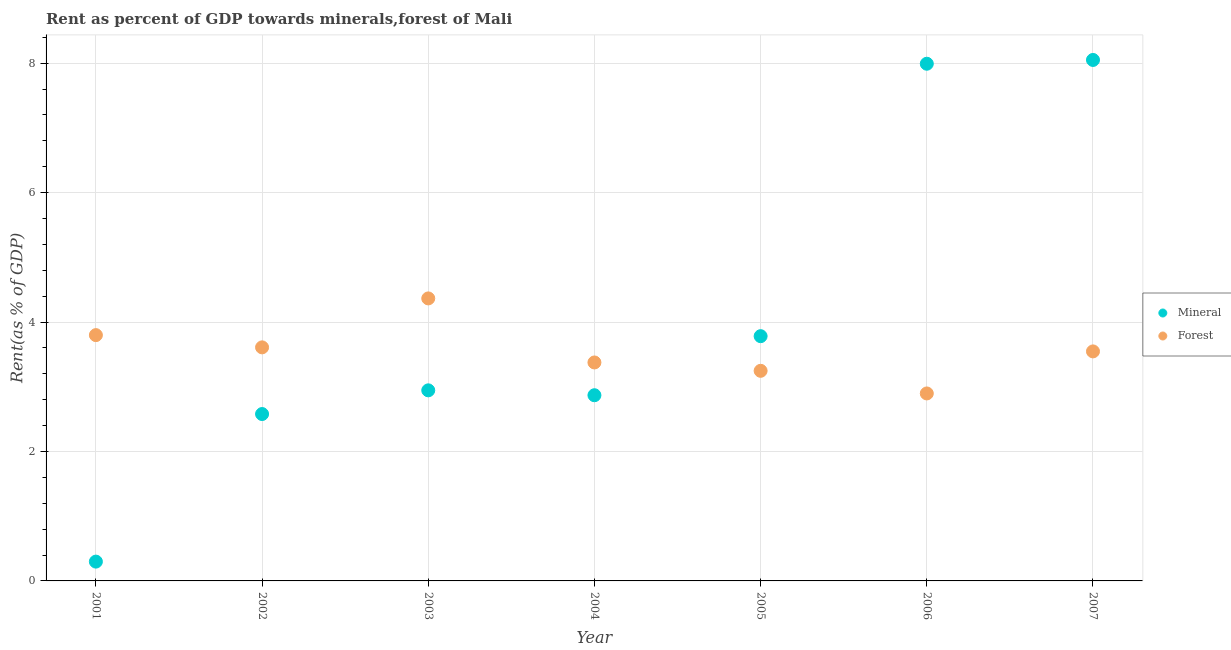How many different coloured dotlines are there?
Ensure brevity in your answer.  2. What is the mineral rent in 2002?
Your answer should be compact. 2.58. Across all years, what is the maximum forest rent?
Provide a short and direct response. 4.36. Across all years, what is the minimum mineral rent?
Make the answer very short. 0.3. In which year was the mineral rent maximum?
Your answer should be compact. 2007. What is the total mineral rent in the graph?
Your answer should be very brief. 28.51. What is the difference between the mineral rent in 2005 and that in 2006?
Keep it short and to the point. -4.21. What is the difference between the mineral rent in 2004 and the forest rent in 2005?
Your answer should be compact. -0.38. What is the average mineral rent per year?
Your response must be concise. 4.07. In the year 2001, what is the difference between the mineral rent and forest rent?
Offer a terse response. -3.5. In how many years, is the forest rent greater than 7.2 %?
Give a very brief answer. 0. What is the ratio of the mineral rent in 2005 to that in 2006?
Give a very brief answer. 0.47. What is the difference between the highest and the second highest forest rent?
Provide a short and direct response. 0.57. What is the difference between the highest and the lowest mineral rent?
Make the answer very short. 7.75. In how many years, is the forest rent greater than the average forest rent taken over all years?
Make the answer very short. 3. Does the mineral rent monotonically increase over the years?
Ensure brevity in your answer.  No. How many dotlines are there?
Your response must be concise. 2. What is the difference between two consecutive major ticks on the Y-axis?
Keep it short and to the point. 2. Does the graph contain grids?
Keep it short and to the point. Yes. Where does the legend appear in the graph?
Provide a short and direct response. Center right. How many legend labels are there?
Your answer should be very brief. 2. What is the title of the graph?
Offer a terse response. Rent as percent of GDP towards minerals,forest of Mali. What is the label or title of the X-axis?
Offer a very short reply. Year. What is the label or title of the Y-axis?
Your response must be concise. Rent(as % of GDP). What is the Rent(as % of GDP) in Mineral in 2001?
Your answer should be very brief. 0.3. What is the Rent(as % of GDP) of Forest in 2001?
Offer a very short reply. 3.8. What is the Rent(as % of GDP) in Mineral in 2002?
Keep it short and to the point. 2.58. What is the Rent(as % of GDP) in Forest in 2002?
Your answer should be compact. 3.61. What is the Rent(as % of GDP) in Mineral in 2003?
Ensure brevity in your answer.  2.94. What is the Rent(as % of GDP) of Forest in 2003?
Provide a succinct answer. 4.36. What is the Rent(as % of GDP) in Mineral in 2004?
Provide a succinct answer. 2.87. What is the Rent(as % of GDP) in Forest in 2004?
Keep it short and to the point. 3.38. What is the Rent(as % of GDP) in Mineral in 2005?
Offer a terse response. 3.78. What is the Rent(as % of GDP) of Forest in 2005?
Your response must be concise. 3.25. What is the Rent(as % of GDP) in Mineral in 2006?
Your answer should be very brief. 7.99. What is the Rent(as % of GDP) in Forest in 2006?
Ensure brevity in your answer.  2.9. What is the Rent(as % of GDP) in Mineral in 2007?
Give a very brief answer. 8.05. What is the Rent(as % of GDP) of Forest in 2007?
Make the answer very short. 3.55. Across all years, what is the maximum Rent(as % of GDP) of Mineral?
Make the answer very short. 8.05. Across all years, what is the maximum Rent(as % of GDP) of Forest?
Make the answer very short. 4.36. Across all years, what is the minimum Rent(as % of GDP) of Mineral?
Offer a terse response. 0.3. Across all years, what is the minimum Rent(as % of GDP) in Forest?
Give a very brief answer. 2.9. What is the total Rent(as % of GDP) in Mineral in the graph?
Offer a very short reply. 28.51. What is the total Rent(as % of GDP) in Forest in the graph?
Give a very brief answer. 24.84. What is the difference between the Rent(as % of GDP) of Mineral in 2001 and that in 2002?
Your answer should be very brief. -2.28. What is the difference between the Rent(as % of GDP) of Forest in 2001 and that in 2002?
Keep it short and to the point. 0.19. What is the difference between the Rent(as % of GDP) of Mineral in 2001 and that in 2003?
Keep it short and to the point. -2.65. What is the difference between the Rent(as % of GDP) of Forest in 2001 and that in 2003?
Your answer should be compact. -0.57. What is the difference between the Rent(as % of GDP) in Mineral in 2001 and that in 2004?
Your answer should be compact. -2.57. What is the difference between the Rent(as % of GDP) in Forest in 2001 and that in 2004?
Make the answer very short. 0.42. What is the difference between the Rent(as % of GDP) in Mineral in 2001 and that in 2005?
Provide a short and direct response. -3.48. What is the difference between the Rent(as % of GDP) of Forest in 2001 and that in 2005?
Make the answer very short. 0.55. What is the difference between the Rent(as % of GDP) of Mineral in 2001 and that in 2006?
Ensure brevity in your answer.  -7.69. What is the difference between the Rent(as % of GDP) of Forest in 2001 and that in 2006?
Your answer should be very brief. 0.9. What is the difference between the Rent(as % of GDP) in Mineral in 2001 and that in 2007?
Offer a terse response. -7.75. What is the difference between the Rent(as % of GDP) of Forest in 2001 and that in 2007?
Make the answer very short. 0.25. What is the difference between the Rent(as % of GDP) of Mineral in 2002 and that in 2003?
Offer a terse response. -0.37. What is the difference between the Rent(as % of GDP) of Forest in 2002 and that in 2003?
Your answer should be compact. -0.76. What is the difference between the Rent(as % of GDP) of Mineral in 2002 and that in 2004?
Give a very brief answer. -0.29. What is the difference between the Rent(as % of GDP) in Forest in 2002 and that in 2004?
Your answer should be compact. 0.23. What is the difference between the Rent(as % of GDP) in Mineral in 2002 and that in 2005?
Keep it short and to the point. -1.2. What is the difference between the Rent(as % of GDP) of Forest in 2002 and that in 2005?
Offer a very short reply. 0.36. What is the difference between the Rent(as % of GDP) of Mineral in 2002 and that in 2006?
Make the answer very short. -5.41. What is the difference between the Rent(as % of GDP) of Forest in 2002 and that in 2006?
Offer a terse response. 0.71. What is the difference between the Rent(as % of GDP) in Mineral in 2002 and that in 2007?
Your answer should be very brief. -5.47. What is the difference between the Rent(as % of GDP) in Forest in 2002 and that in 2007?
Your response must be concise. 0.06. What is the difference between the Rent(as % of GDP) in Mineral in 2003 and that in 2004?
Make the answer very short. 0.08. What is the difference between the Rent(as % of GDP) in Forest in 2003 and that in 2004?
Your answer should be very brief. 0.99. What is the difference between the Rent(as % of GDP) in Mineral in 2003 and that in 2005?
Make the answer very short. -0.84. What is the difference between the Rent(as % of GDP) of Forest in 2003 and that in 2005?
Make the answer very short. 1.12. What is the difference between the Rent(as % of GDP) in Mineral in 2003 and that in 2006?
Provide a succinct answer. -5.05. What is the difference between the Rent(as % of GDP) of Forest in 2003 and that in 2006?
Keep it short and to the point. 1.47. What is the difference between the Rent(as % of GDP) of Mineral in 2003 and that in 2007?
Give a very brief answer. -5.1. What is the difference between the Rent(as % of GDP) of Forest in 2003 and that in 2007?
Give a very brief answer. 0.82. What is the difference between the Rent(as % of GDP) in Mineral in 2004 and that in 2005?
Keep it short and to the point. -0.91. What is the difference between the Rent(as % of GDP) of Forest in 2004 and that in 2005?
Your answer should be very brief. 0.13. What is the difference between the Rent(as % of GDP) of Mineral in 2004 and that in 2006?
Ensure brevity in your answer.  -5.12. What is the difference between the Rent(as % of GDP) of Forest in 2004 and that in 2006?
Your answer should be very brief. 0.48. What is the difference between the Rent(as % of GDP) in Mineral in 2004 and that in 2007?
Your answer should be compact. -5.18. What is the difference between the Rent(as % of GDP) in Forest in 2004 and that in 2007?
Provide a succinct answer. -0.17. What is the difference between the Rent(as % of GDP) in Mineral in 2005 and that in 2006?
Your answer should be very brief. -4.21. What is the difference between the Rent(as % of GDP) in Forest in 2005 and that in 2006?
Your answer should be compact. 0.35. What is the difference between the Rent(as % of GDP) in Mineral in 2005 and that in 2007?
Offer a very short reply. -4.27. What is the difference between the Rent(as % of GDP) of Forest in 2005 and that in 2007?
Your answer should be very brief. -0.3. What is the difference between the Rent(as % of GDP) of Mineral in 2006 and that in 2007?
Provide a succinct answer. -0.06. What is the difference between the Rent(as % of GDP) of Forest in 2006 and that in 2007?
Your response must be concise. -0.65. What is the difference between the Rent(as % of GDP) in Mineral in 2001 and the Rent(as % of GDP) in Forest in 2002?
Offer a very short reply. -3.31. What is the difference between the Rent(as % of GDP) in Mineral in 2001 and the Rent(as % of GDP) in Forest in 2003?
Offer a terse response. -4.07. What is the difference between the Rent(as % of GDP) of Mineral in 2001 and the Rent(as % of GDP) of Forest in 2004?
Make the answer very short. -3.08. What is the difference between the Rent(as % of GDP) of Mineral in 2001 and the Rent(as % of GDP) of Forest in 2005?
Your answer should be compact. -2.95. What is the difference between the Rent(as % of GDP) in Mineral in 2001 and the Rent(as % of GDP) in Forest in 2006?
Offer a very short reply. -2.6. What is the difference between the Rent(as % of GDP) in Mineral in 2001 and the Rent(as % of GDP) in Forest in 2007?
Offer a very short reply. -3.25. What is the difference between the Rent(as % of GDP) of Mineral in 2002 and the Rent(as % of GDP) of Forest in 2003?
Provide a succinct answer. -1.79. What is the difference between the Rent(as % of GDP) in Mineral in 2002 and the Rent(as % of GDP) in Forest in 2004?
Keep it short and to the point. -0.8. What is the difference between the Rent(as % of GDP) of Mineral in 2002 and the Rent(as % of GDP) of Forest in 2005?
Keep it short and to the point. -0.67. What is the difference between the Rent(as % of GDP) in Mineral in 2002 and the Rent(as % of GDP) in Forest in 2006?
Make the answer very short. -0.32. What is the difference between the Rent(as % of GDP) in Mineral in 2002 and the Rent(as % of GDP) in Forest in 2007?
Keep it short and to the point. -0.97. What is the difference between the Rent(as % of GDP) of Mineral in 2003 and the Rent(as % of GDP) of Forest in 2004?
Ensure brevity in your answer.  -0.43. What is the difference between the Rent(as % of GDP) in Mineral in 2003 and the Rent(as % of GDP) in Forest in 2005?
Your response must be concise. -0.3. What is the difference between the Rent(as % of GDP) of Mineral in 2003 and the Rent(as % of GDP) of Forest in 2006?
Offer a very short reply. 0.05. What is the difference between the Rent(as % of GDP) in Mineral in 2003 and the Rent(as % of GDP) in Forest in 2007?
Your response must be concise. -0.6. What is the difference between the Rent(as % of GDP) in Mineral in 2004 and the Rent(as % of GDP) in Forest in 2005?
Provide a short and direct response. -0.38. What is the difference between the Rent(as % of GDP) in Mineral in 2004 and the Rent(as % of GDP) in Forest in 2006?
Ensure brevity in your answer.  -0.03. What is the difference between the Rent(as % of GDP) in Mineral in 2004 and the Rent(as % of GDP) in Forest in 2007?
Provide a succinct answer. -0.68. What is the difference between the Rent(as % of GDP) in Mineral in 2005 and the Rent(as % of GDP) in Forest in 2006?
Ensure brevity in your answer.  0.88. What is the difference between the Rent(as % of GDP) in Mineral in 2005 and the Rent(as % of GDP) in Forest in 2007?
Your answer should be very brief. 0.24. What is the difference between the Rent(as % of GDP) of Mineral in 2006 and the Rent(as % of GDP) of Forest in 2007?
Your answer should be compact. 4.44. What is the average Rent(as % of GDP) in Mineral per year?
Your response must be concise. 4.07. What is the average Rent(as % of GDP) in Forest per year?
Your answer should be very brief. 3.55. In the year 2001, what is the difference between the Rent(as % of GDP) in Mineral and Rent(as % of GDP) in Forest?
Ensure brevity in your answer.  -3.5. In the year 2002, what is the difference between the Rent(as % of GDP) in Mineral and Rent(as % of GDP) in Forest?
Provide a short and direct response. -1.03. In the year 2003, what is the difference between the Rent(as % of GDP) in Mineral and Rent(as % of GDP) in Forest?
Give a very brief answer. -1.42. In the year 2004, what is the difference between the Rent(as % of GDP) in Mineral and Rent(as % of GDP) in Forest?
Give a very brief answer. -0.51. In the year 2005, what is the difference between the Rent(as % of GDP) of Mineral and Rent(as % of GDP) of Forest?
Offer a very short reply. 0.54. In the year 2006, what is the difference between the Rent(as % of GDP) in Mineral and Rent(as % of GDP) in Forest?
Make the answer very short. 5.09. In the year 2007, what is the difference between the Rent(as % of GDP) in Mineral and Rent(as % of GDP) in Forest?
Make the answer very short. 4.5. What is the ratio of the Rent(as % of GDP) in Mineral in 2001 to that in 2002?
Make the answer very short. 0.12. What is the ratio of the Rent(as % of GDP) in Forest in 2001 to that in 2002?
Your answer should be compact. 1.05. What is the ratio of the Rent(as % of GDP) of Mineral in 2001 to that in 2003?
Your answer should be very brief. 0.1. What is the ratio of the Rent(as % of GDP) of Forest in 2001 to that in 2003?
Keep it short and to the point. 0.87. What is the ratio of the Rent(as % of GDP) of Mineral in 2001 to that in 2004?
Ensure brevity in your answer.  0.1. What is the ratio of the Rent(as % of GDP) of Forest in 2001 to that in 2004?
Provide a succinct answer. 1.13. What is the ratio of the Rent(as % of GDP) of Mineral in 2001 to that in 2005?
Offer a very short reply. 0.08. What is the ratio of the Rent(as % of GDP) of Forest in 2001 to that in 2005?
Your answer should be very brief. 1.17. What is the ratio of the Rent(as % of GDP) of Mineral in 2001 to that in 2006?
Provide a succinct answer. 0.04. What is the ratio of the Rent(as % of GDP) in Forest in 2001 to that in 2006?
Provide a succinct answer. 1.31. What is the ratio of the Rent(as % of GDP) in Mineral in 2001 to that in 2007?
Provide a short and direct response. 0.04. What is the ratio of the Rent(as % of GDP) of Forest in 2001 to that in 2007?
Your answer should be very brief. 1.07. What is the ratio of the Rent(as % of GDP) of Mineral in 2002 to that in 2003?
Provide a succinct answer. 0.88. What is the ratio of the Rent(as % of GDP) of Forest in 2002 to that in 2003?
Provide a short and direct response. 0.83. What is the ratio of the Rent(as % of GDP) in Mineral in 2002 to that in 2004?
Your answer should be compact. 0.9. What is the ratio of the Rent(as % of GDP) in Forest in 2002 to that in 2004?
Your response must be concise. 1.07. What is the ratio of the Rent(as % of GDP) of Mineral in 2002 to that in 2005?
Offer a terse response. 0.68. What is the ratio of the Rent(as % of GDP) in Forest in 2002 to that in 2005?
Ensure brevity in your answer.  1.11. What is the ratio of the Rent(as % of GDP) of Mineral in 2002 to that in 2006?
Keep it short and to the point. 0.32. What is the ratio of the Rent(as % of GDP) of Forest in 2002 to that in 2006?
Your response must be concise. 1.25. What is the ratio of the Rent(as % of GDP) of Mineral in 2002 to that in 2007?
Your response must be concise. 0.32. What is the ratio of the Rent(as % of GDP) of Forest in 2002 to that in 2007?
Your answer should be very brief. 1.02. What is the ratio of the Rent(as % of GDP) in Mineral in 2003 to that in 2004?
Provide a short and direct response. 1.03. What is the ratio of the Rent(as % of GDP) of Forest in 2003 to that in 2004?
Your answer should be very brief. 1.29. What is the ratio of the Rent(as % of GDP) in Mineral in 2003 to that in 2005?
Your response must be concise. 0.78. What is the ratio of the Rent(as % of GDP) in Forest in 2003 to that in 2005?
Your answer should be compact. 1.34. What is the ratio of the Rent(as % of GDP) in Mineral in 2003 to that in 2006?
Your answer should be very brief. 0.37. What is the ratio of the Rent(as % of GDP) in Forest in 2003 to that in 2006?
Your response must be concise. 1.51. What is the ratio of the Rent(as % of GDP) of Mineral in 2003 to that in 2007?
Your answer should be compact. 0.37. What is the ratio of the Rent(as % of GDP) in Forest in 2003 to that in 2007?
Your response must be concise. 1.23. What is the ratio of the Rent(as % of GDP) in Mineral in 2004 to that in 2005?
Make the answer very short. 0.76. What is the ratio of the Rent(as % of GDP) in Forest in 2004 to that in 2005?
Give a very brief answer. 1.04. What is the ratio of the Rent(as % of GDP) in Mineral in 2004 to that in 2006?
Make the answer very short. 0.36. What is the ratio of the Rent(as % of GDP) of Forest in 2004 to that in 2006?
Your response must be concise. 1.17. What is the ratio of the Rent(as % of GDP) of Mineral in 2004 to that in 2007?
Offer a terse response. 0.36. What is the ratio of the Rent(as % of GDP) in Forest in 2004 to that in 2007?
Provide a short and direct response. 0.95. What is the ratio of the Rent(as % of GDP) in Mineral in 2005 to that in 2006?
Provide a short and direct response. 0.47. What is the ratio of the Rent(as % of GDP) in Forest in 2005 to that in 2006?
Ensure brevity in your answer.  1.12. What is the ratio of the Rent(as % of GDP) of Mineral in 2005 to that in 2007?
Give a very brief answer. 0.47. What is the ratio of the Rent(as % of GDP) of Forest in 2005 to that in 2007?
Ensure brevity in your answer.  0.92. What is the ratio of the Rent(as % of GDP) in Forest in 2006 to that in 2007?
Give a very brief answer. 0.82. What is the difference between the highest and the second highest Rent(as % of GDP) of Mineral?
Offer a very short reply. 0.06. What is the difference between the highest and the second highest Rent(as % of GDP) of Forest?
Ensure brevity in your answer.  0.57. What is the difference between the highest and the lowest Rent(as % of GDP) in Mineral?
Give a very brief answer. 7.75. What is the difference between the highest and the lowest Rent(as % of GDP) in Forest?
Your answer should be compact. 1.47. 